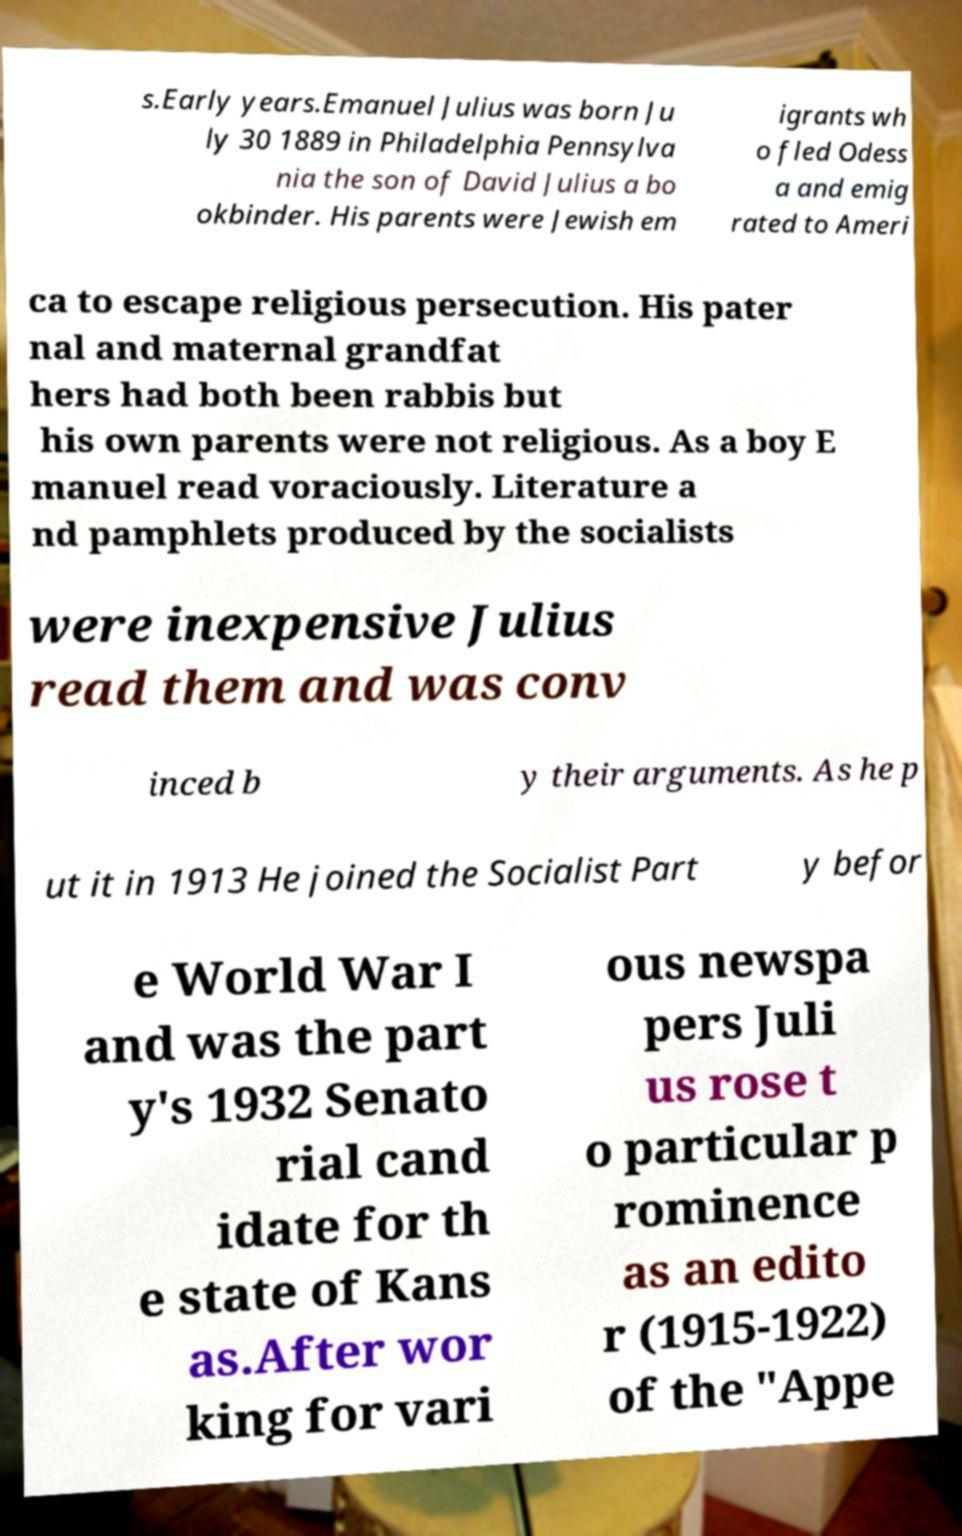There's text embedded in this image that I need extracted. Can you transcribe it verbatim? s.Early years.Emanuel Julius was born Ju ly 30 1889 in Philadelphia Pennsylva nia the son of David Julius a bo okbinder. His parents were Jewish em igrants wh o fled Odess a and emig rated to Ameri ca to escape religious persecution. His pater nal and maternal grandfat hers had both been rabbis but his own parents were not religious. As a boy E manuel read voraciously. Literature a nd pamphlets produced by the socialists were inexpensive Julius read them and was conv inced b y their arguments. As he p ut it in 1913 He joined the Socialist Part y befor e World War I and was the part y's 1932 Senato rial cand idate for th e state of Kans as.After wor king for vari ous newspa pers Juli us rose t o particular p rominence as an edito r (1915-1922) of the "Appe 